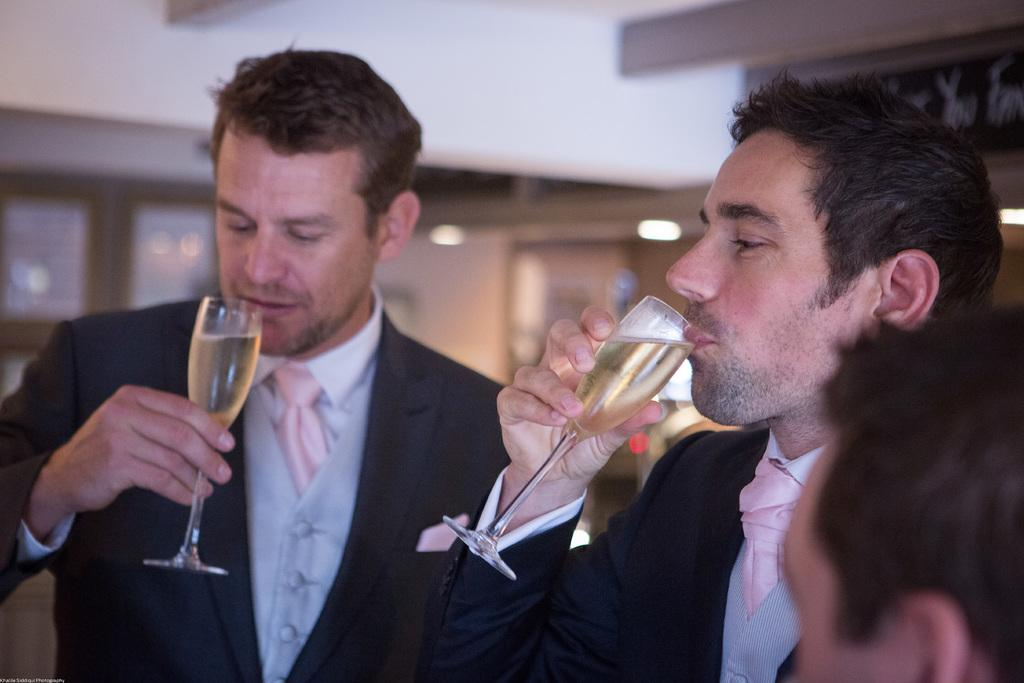How many people are present in the image? There are two persons standing in the image. What are the two persons doing in the image? The two persons are drinking a glass of wine. Is there anyone else present in the image? Yes, there is another person in the right corner of the image. What type of garden can be seen in the image? There is no garden present in the image. How does the jellyfish contribute to the scene in the image? There is no jellyfish present in the image. 